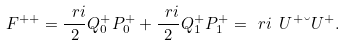Convert formula to latex. <formula><loc_0><loc_0><loc_500><loc_500>F ^ { + + } = \frac { \ r i } { 2 } Q _ { 0 } ^ { + } P _ { 0 } ^ { + } + \frac { \ r i } { 2 } Q _ { 1 } ^ { + } P _ { 1 } ^ { + } = \ r i \ U ^ { + } \breve { \ } U ^ { + } .</formula> 